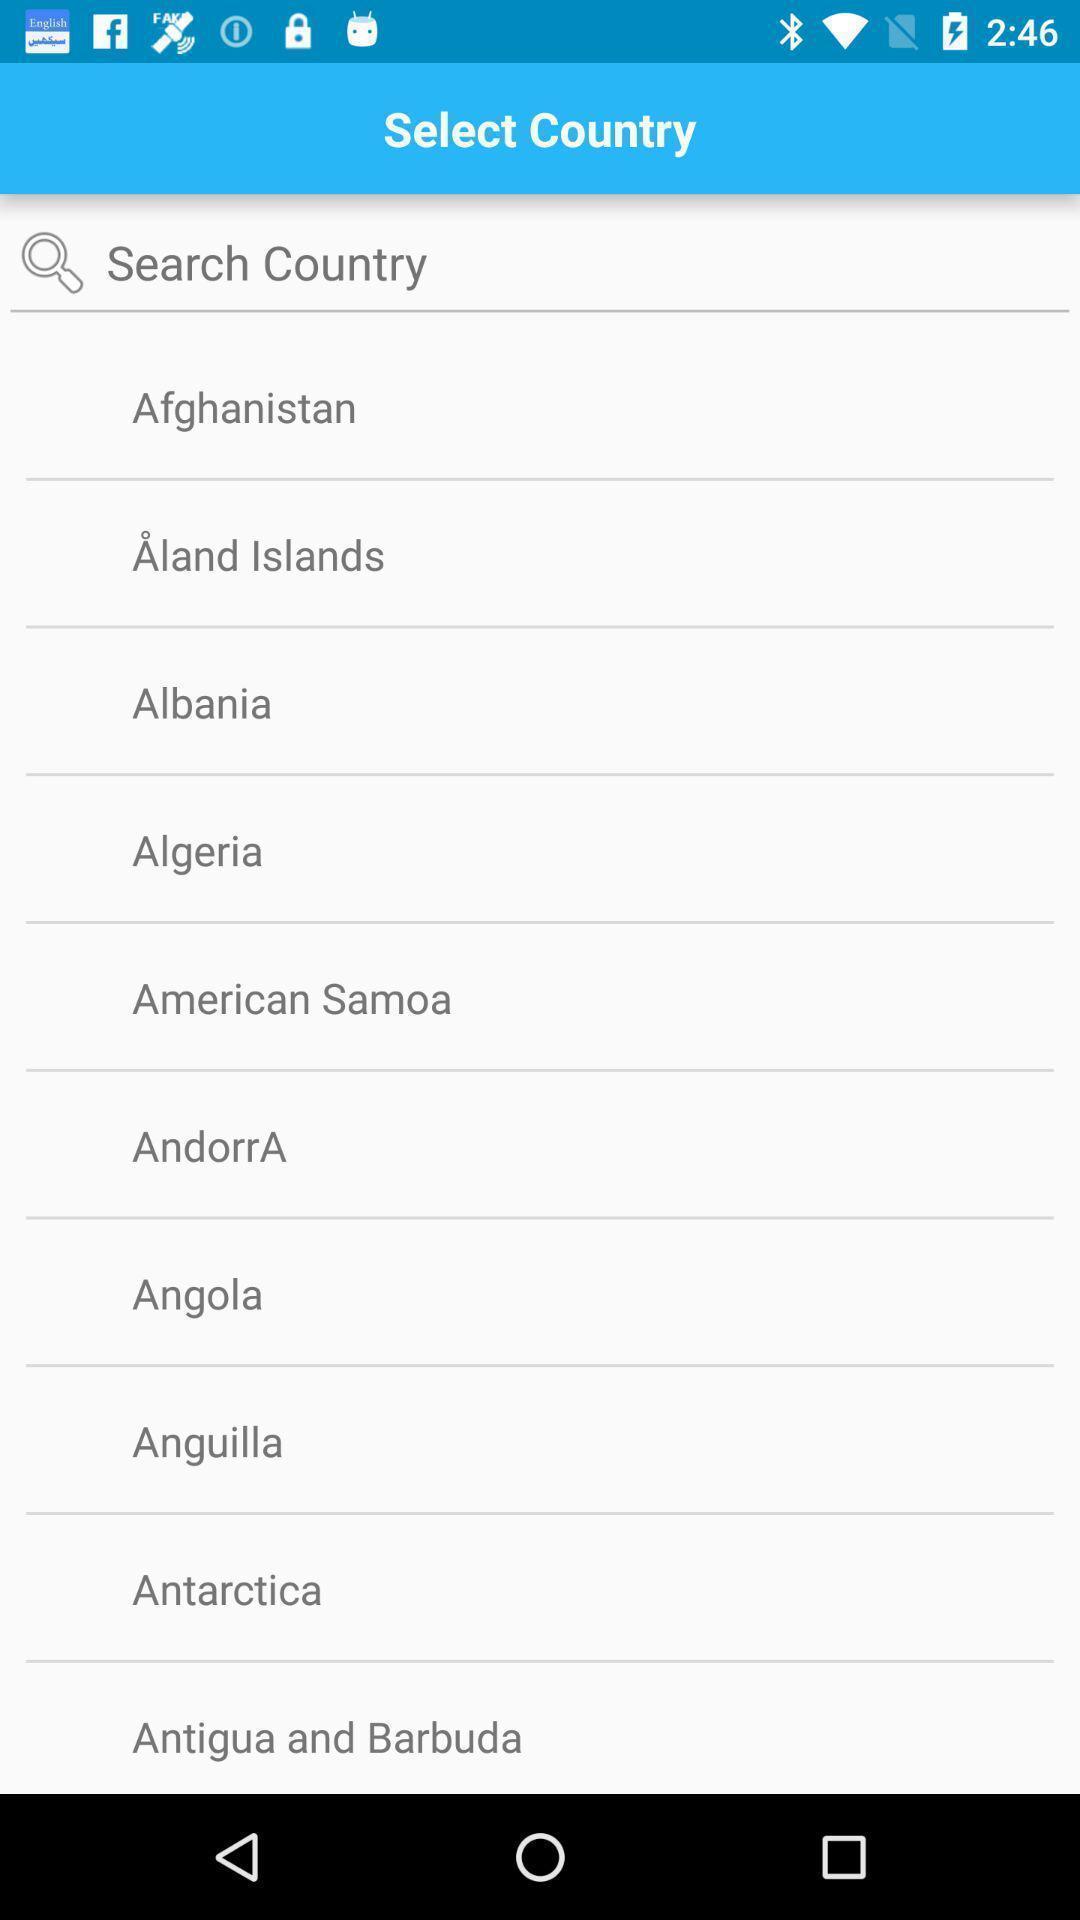Tell me about the visual elements in this screen capture. Search option to choose country. 